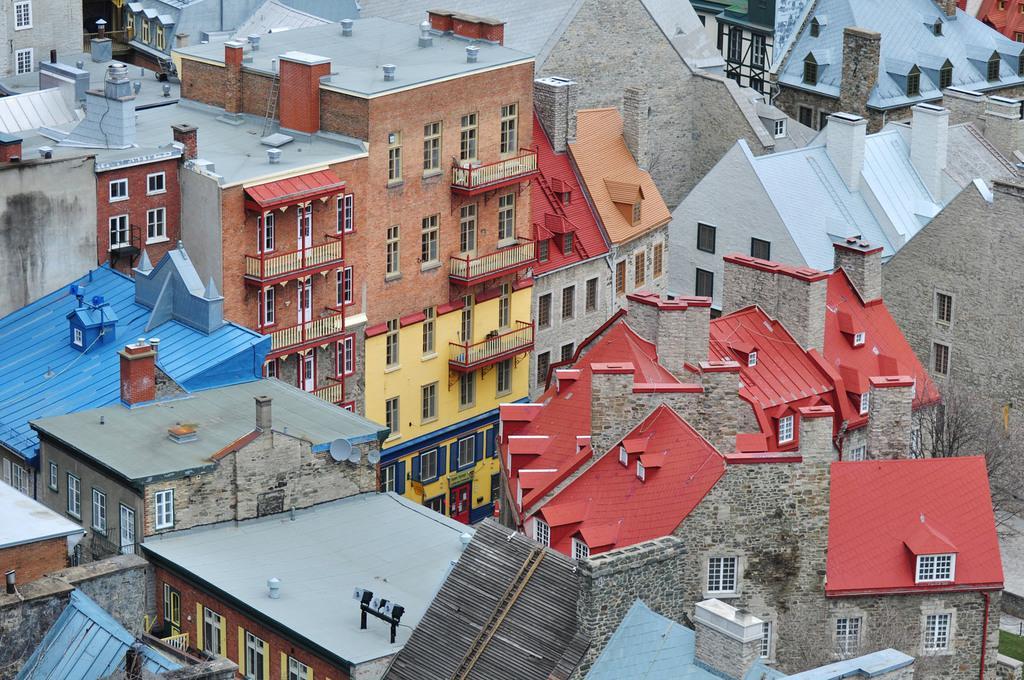Please provide a concise description of this image. In this image I can see few buildings. They are in different color. We can see windows and balcony. 